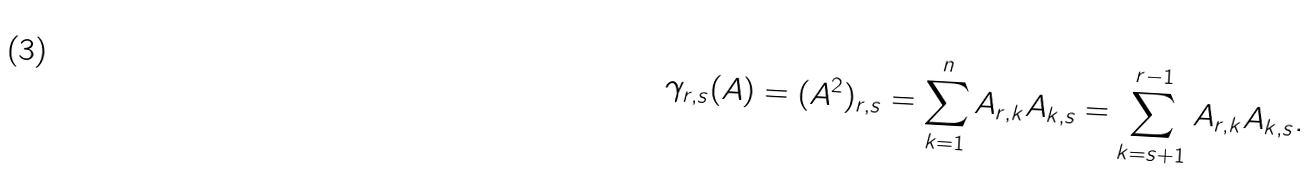Convert formula to latex. <formula><loc_0><loc_0><loc_500><loc_500>\gamma _ { r , s } ( A ) = ( A ^ { 2 } ) _ { r , s } = \sum _ { k = 1 } ^ { n } A _ { r , k } A _ { k , s } = \sum _ { k = s + 1 } ^ { r - 1 } A _ { r , k } A _ { k , s } .</formula> 